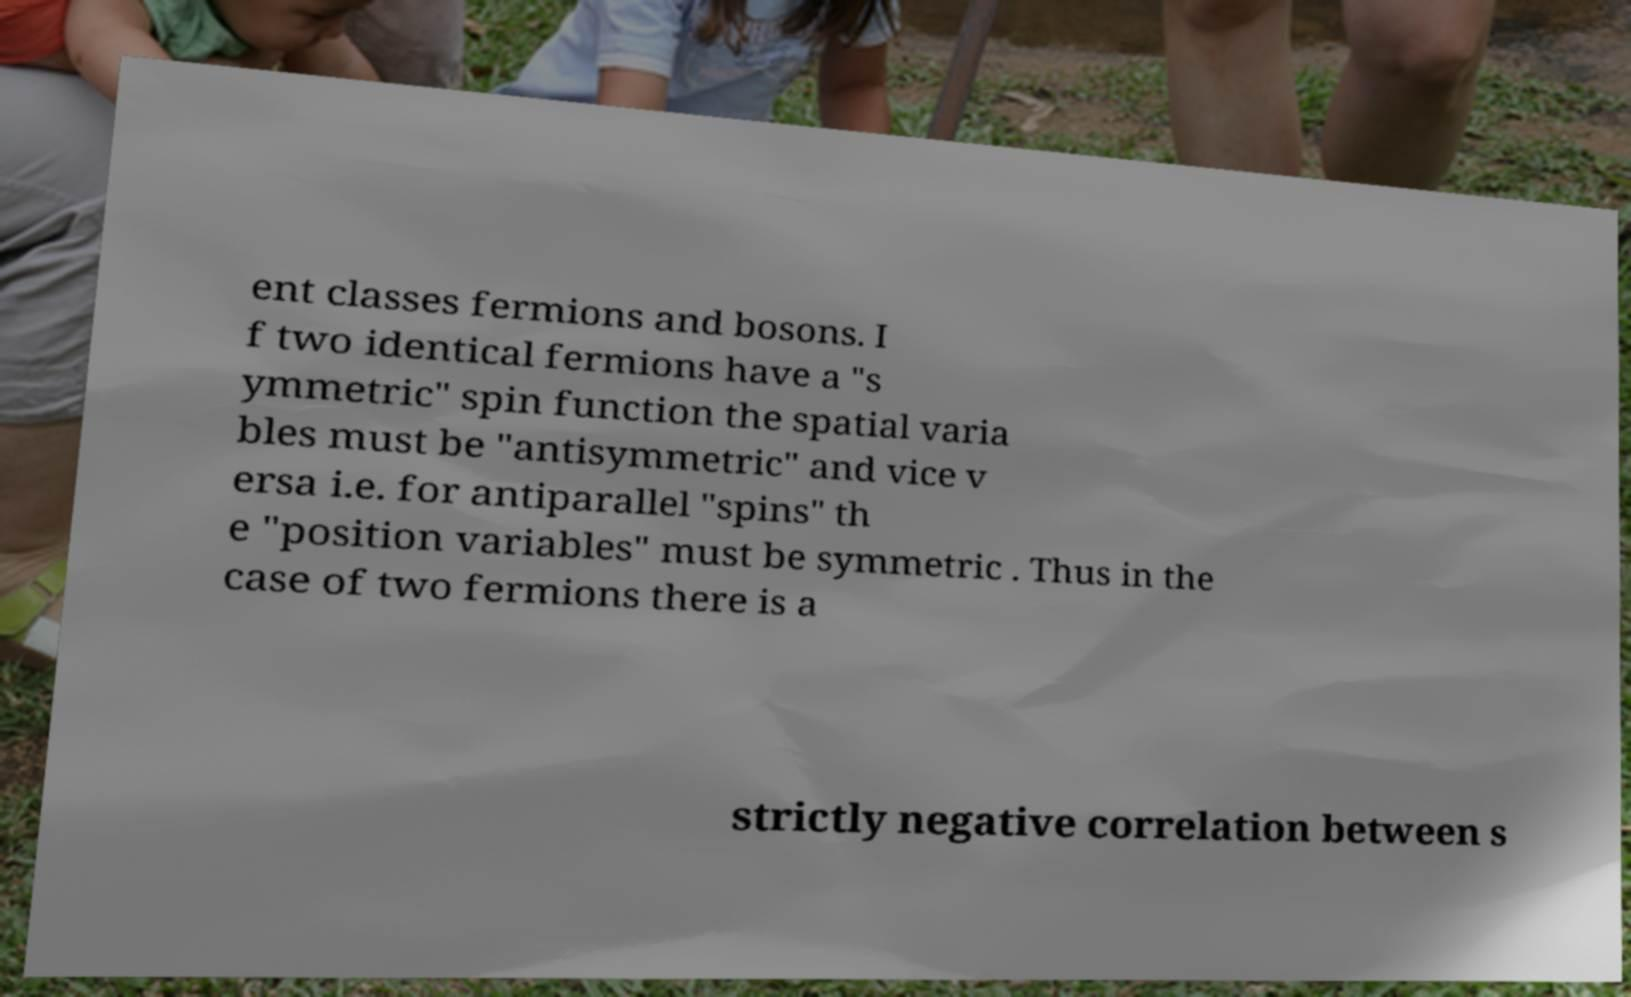For documentation purposes, I need the text within this image transcribed. Could you provide that? ent classes fermions and bosons. I f two identical fermions have a "s ymmetric" spin function the spatial varia bles must be "antisymmetric" and vice v ersa i.e. for antiparallel "spins" th e "position variables" must be symmetric . Thus in the case of two fermions there is a strictly negative correlation between s 